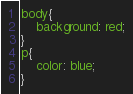<code> <loc_0><loc_0><loc_500><loc_500><_CSS_>body{
    background: red;
}
p{
    color: blue;
}</code> 